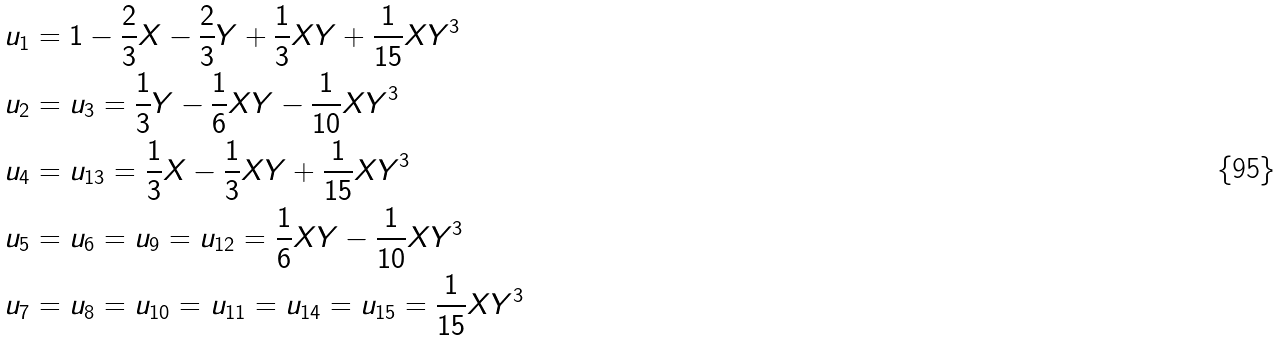<formula> <loc_0><loc_0><loc_500><loc_500>u _ { 1 } & = 1 - \frac { 2 } { 3 } X - \frac { 2 } { 3 } Y + \frac { 1 } { 3 } X Y + \frac { 1 } { 1 5 } X Y ^ { 3 } \\ u _ { 2 } & = u _ { 3 } = \frac { 1 } { 3 } Y - \frac { 1 } { 6 } X Y - \frac { 1 } { 1 0 } X Y ^ { 3 } \\ u _ { 4 } & = u _ { 1 3 } = \frac { 1 } { 3 } X - \frac { 1 } { 3 } X Y + \frac { 1 } { 1 5 } X Y ^ { 3 } \\ u _ { 5 } & = u _ { 6 } = u _ { 9 } = u _ { 1 2 } = \frac { 1 } { 6 } X Y - \frac { 1 } { 1 0 } X Y ^ { 3 } \\ u _ { 7 } & = u _ { 8 } = u _ { 1 0 } = u _ { 1 1 } = u _ { 1 4 } = u _ { 1 5 } = \frac { 1 } { 1 5 } X Y ^ { 3 }</formula> 